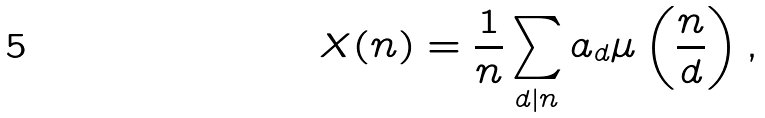<formula> <loc_0><loc_0><loc_500><loc_500>X ( n ) = \frac { 1 } { n } \sum _ { d | n } a _ { d } \mu \left ( \frac { n } { d } \right ) ,</formula> 